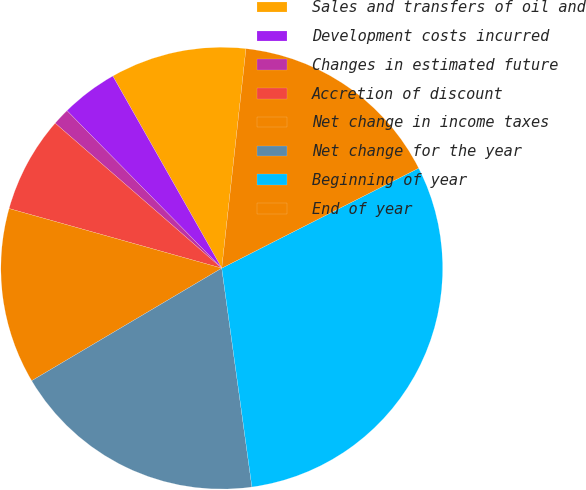Convert chart to OTSL. <chart><loc_0><loc_0><loc_500><loc_500><pie_chart><fcel>Sales and transfers of oil and<fcel>Development costs incurred<fcel>Changes in estimated future<fcel>Accretion of discount<fcel>Net change in income taxes<fcel>Net change for the year<fcel>Beginning of year<fcel>End of year<nl><fcel>9.96%<fcel>4.15%<fcel>1.24%<fcel>7.05%<fcel>12.86%<fcel>18.67%<fcel>30.3%<fcel>15.77%<nl></chart> 